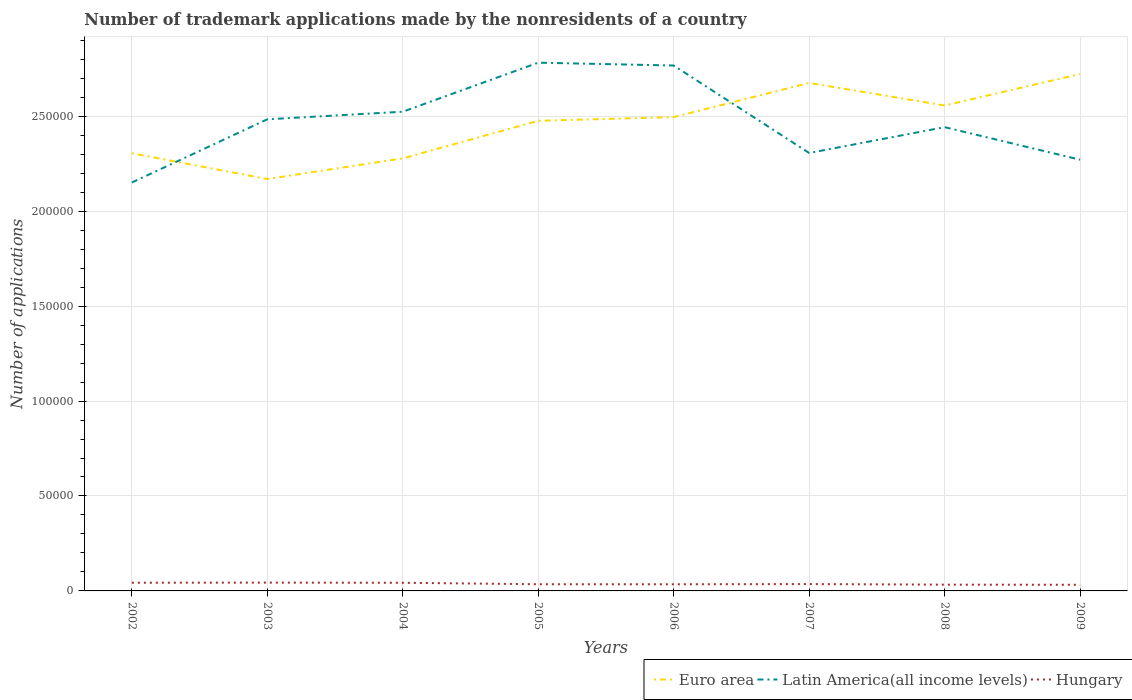How many different coloured lines are there?
Give a very brief answer. 3. Across all years, what is the maximum number of trademark applications made by the nonresidents in Hungary?
Ensure brevity in your answer.  3240. In which year was the number of trademark applications made by the nonresidents in Hungary maximum?
Offer a very short reply. 2009. What is the total number of trademark applications made by the nonresidents in Hungary in the graph?
Provide a short and direct response. 21. What is the difference between the highest and the second highest number of trademark applications made by the nonresidents in Latin America(all income levels)?
Give a very brief answer. 6.31e+04. Is the number of trademark applications made by the nonresidents in Euro area strictly greater than the number of trademark applications made by the nonresidents in Hungary over the years?
Your answer should be compact. No. How many lines are there?
Your answer should be very brief. 3. Are the values on the major ticks of Y-axis written in scientific E-notation?
Give a very brief answer. No. Does the graph contain any zero values?
Keep it short and to the point. No. What is the title of the graph?
Give a very brief answer. Number of trademark applications made by the nonresidents of a country. What is the label or title of the X-axis?
Keep it short and to the point. Years. What is the label or title of the Y-axis?
Ensure brevity in your answer.  Number of applications. What is the Number of applications of Euro area in 2002?
Provide a succinct answer. 2.30e+05. What is the Number of applications in Latin America(all income levels) in 2002?
Your answer should be compact. 2.15e+05. What is the Number of applications in Hungary in 2002?
Make the answer very short. 4316. What is the Number of applications of Euro area in 2003?
Your answer should be compact. 2.17e+05. What is the Number of applications of Latin America(all income levels) in 2003?
Provide a succinct answer. 2.48e+05. What is the Number of applications in Hungary in 2003?
Ensure brevity in your answer.  4386. What is the Number of applications of Euro area in 2004?
Provide a short and direct response. 2.28e+05. What is the Number of applications of Latin America(all income levels) in 2004?
Your answer should be very brief. 2.52e+05. What is the Number of applications in Hungary in 2004?
Ensure brevity in your answer.  4295. What is the Number of applications of Euro area in 2005?
Provide a succinct answer. 2.48e+05. What is the Number of applications in Latin America(all income levels) in 2005?
Keep it short and to the point. 2.78e+05. What is the Number of applications of Hungary in 2005?
Make the answer very short. 3515. What is the Number of applications of Euro area in 2006?
Your answer should be compact. 2.50e+05. What is the Number of applications of Latin America(all income levels) in 2006?
Give a very brief answer. 2.77e+05. What is the Number of applications in Hungary in 2006?
Offer a terse response. 3492. What is the Number of applications of Euro area in 2007?
Your answer should be very brief. 2.68e+05. What is the Number of applications in Latin America(all income levels) in 2007?
Ensure brevity in your answer.  2.31e+05. What is the Number of applications in Hungary in 2007?
Ensure brevity in your answer.  3615. What is the Number of applications of Euro area in 2008?
Provide a short and direct response. 2.56e+05. What is the Number of applications of Latin America(all income levels) in 2008?
Ensure brevity in your answer.  2.44e+05. What is the Number of applications of Hungary in 2008?
Provide a short and direct response. 3296. What is the Number of applications of Euro area in 2009?
Ensure brevity in your answer.  2.72e+05. What is the Number of applications of Latin America(all income levels) in 2009?
Your answer should be compact. 2.27e+05. What is the Number of applications of Hungary in 2009?
Your answer should be very brief. 3240. Across all years, what is the maximum Number of applications in Euro area?
Give a very brief answer. 2.72e+05. Across all years, what is the maximum Number of applications in Latin America(all income levels)?
Keep it short and to the point. 2.78e+05. Across all years, what is the maximum Number of applications of Hungary?
Provide a succinct answer. 4386. Across all years, what is the minimum Number of applications of Euro area?
Your response must be concise. 2.17e+05. Across all years, what is the minimum Number of applications of Latin America(all income levels)?
Give a very brief answer. 2.15e+05. Across all years, what is the minimum Number of applications in Hungary?
Offer a very short reply. 3240. What is the total Number of applications in Euro area in the graph?
Your response must be concise. 1.97e+06. What is the total Number of applications in Latin America(all income levels) in the graph?
Your answer should be compact. 1.97e+06. What is the total Number of applications in Hungary in the graph?
Your response must be concise. 3.02e+04. What is the difference between the Number of applications of Euro area in 2002 and that in 2003?
Your answer should be very brief. 1.36e+04. What is the difference between the Number of applications in Latin America(all income levels) in 2002 and that in 2003?
Make the answer very short. -3.33e+04. What is the difference between the Number of applications in Hungary in 2002 and that in 2003?
Keep it short and to the point. -70. What is the difference between the Number of applications in Euro area in 2002 and that in 2004?
Your answer should be very brief. 2697. What is the difference between the Number of applications in Latin America(all income levels) in 2002 and that in 2004?
Your answer should be compact. -3.73e+04. What is the difference between the Number of applications in Hungary in 2002 and that in 2004?
Your answer should be very brief. 21. What is the difference between the Number of applications of Euro area in 2002 and that in 2005?
Keep it short and to the point. -1.71e+04. What is the difference between the Number of applications in Latin America(all income levels) in 2002 and that in 2005?
Ensure brevity in your answer.  -6.31e+04. What is the difference between the Number of applications in Hungary in 2002 and that in 2005?
Give a very brief answer. 801. What is the difference between the Number of applications in Euro area in 2002 and that in 2006?
Your answer should be very brief. -1.90e+04. What is the difference between the Number of applications in Latin America(all income levels) in 2002 and that in 2006?
Provide a succinct answer. -6.16e+04. What is the difference between the Number of applications in Hungary in 2002 and that in 2006?
Offer a terse response. 824. What is the difference between the Number of applications of Euro area in 2002 and that in 2007?
Keep it short and to the point. -3.70e+04. What is the difference between the Number of applications of Latin America(all income levels) in 2002 and that in 2007?
Provide a short and direct response. -1.55e+04. What is the difference between the Number of applications of Hungary in 2002 and that in 2007?
Make the answer very short. 701. What is the difference between the Number of applications of Euro area in 2002 and that in 2008?
Your response must be concise. -2.52e+04. What is the difference between the Number of applications in Latin America(all income levels) in 2002 and that in 2008?
Offer a very short reply. -2.91e+04. What is the difference between the Number of applications of Hungary in 2002 and that in 2008?
Your answer should be compact. 1020. What is the difference between the Number of applications of Euro area in 2002 and that in 2009?
Your answer should be very brief. -4.17e+04. What is the difference between the Number of applications of Latin America(all income levels) in 2002 and that in 2009?
Your answer should be very brief. -1.20e+04. What is the difference between the Number of applications of Hungary in 2002 and that in 2009?
Your answer should be compact. 1076. What is the difference between the Number of applications in Euro area in 2003 and that in 2004?
Your response must be concise. -1.09e+04. What is the difference between the Number of applications in Latin America(all income levels) in 2003 and that in 2004?
Give a very brief answer. -4004. What is the difference between the Number of applications of Hungary in 2003 and that in 2004?
Offer a very short reply. 91. What is the difference between the Number of applications of Euro area in 2003 and that in 2005?
Provide a succinct answer. -3.07e+04. What is the difference between the Number of applications in Latin America(all income levels) in 2003 and that in 2005?
Your response must be concise. -2.98e+04. What is the difference between the Number of applications of Hungary in 2003 and that in 2005?
Ensure brevity in your answer.  871. What is the difference between the Number of applications in Euro area in 2003 and that in 2006?
Your answer should be compact. -3.26e+04. What is the difference between the Number of applications of Latin America(all income levels) in 2003 and that in 2006?
Make the answer very short. -2.83e+04. What is the difference between the Number of applications of Hungary in 2003 and that in 2006?
Your answer should be compact. 894. What is the difference between the Number of applications in Euro area in 2003 and that in 2007?
Provide a succinct answer. -5.06e+04. What is the difference between the Number of applications in Latin America(all income levels) in 2003 and that in 2007?
Your answer should be very brief. 1.77e+04. What is the difference between the Number of applications in Hungary in 2003 and that in 2007?
Give a very brief answer. 771. What is the difference between the Number of applications of Euro area in 2003 and that in 2008?
Keep it short and to the point. -3.87e+04. What is the difference between the Number of applications in Latin America(all income levels) in 2003 and that in 2008?
Provide a succinct answer. 4135. What is the difference between the Number of applications in Hungary in 2003 and that in 2008?
Offer a terse response. 1090. What is the difference between the Number of applications of Euro area in 2003 and that in 2009?
Your answer should be compact. -5.53e+04. What is the difference between the Number of applications in Latin America(all income levels) in 2003 and that in 2009?
Your answer should be compact. 2.13e+04. What is the difference between the Number of applications in Hungary in 2003 and that in 2009?
Provide a succinct answer. 1146. What is the difference between the Number of applications in Euro area in 2004 and that in 2005?
Provide a succinct answer. -1.98e+04. What is the difference between the Number of applications of Latin America(all income levels) in 2004 and that in 2005?
Make the answer very short. -2.58e+04. What is the difference between the Number of applications of Hungary in 2004 and that in 2005?
Keep it short and to the point. 780. What is the difference between the Number of applications of Euro area in 2004 and that in 2006?
Make the answer very short. -2.17e+04. What is the difference between the Number of applications of Latin America(all income levels) in 2004 and that in 2006?
Ensure brevity in your answer.  -2.43e+04. What is the difference between the Number of applications of Hungary in 2004 and that in 2006?
Your answer should be very brief. 803. What is the difference between the Number of applications of Euro area in 2004 and that in 2007?
Offer a very short reply. -3.97e+04. What is the difference between the Number of applications in Latin America(all income levels) in 2004 and that in 2007?
Keep it short and to the point. 2.17e+04. What is the difference between the Number of applications in Hungary in 2004 and that in 2007?
Your answer should be very brief. 680. What is the difference between the Number of applications in Euro area in 2004 and that in 2008?
Give a very brief answer. -2.78e+04. What is the difference between the Number of applications of Latin America(all income levels) in 2004 and that in 2008?
Provide a short and direct response. 8139. What is the difference between the Number of applications of Hungary in 2004 and that in 2008?
Offer a terse response. 999. What is the difference between the Number of applications in Euro area in 2004 and that in 2009?
Make the answer very short. -4.44e+04. What is the difference between the Number of applications in Latin America(all income levels) in 2004 and that in 2009?
Ensure brevity in your answer.  2.53e+04. What is the difference between the Number of applications of Hungary in 2004 and that in 2009?
Your response must be concise. 1055. What is the difference between the Number of applications of Euro area in 2005 and that in 2006?
Ensure brevity in your answer.  -1953. What is the difference between the Number of applications in Latin America(all income levels) in 2005 and that in 2006?
Provide a short and direct response. 1492. What is the difference between the Number of applications of Euro area in 2005 and that in 2007?
Keep it short and to the point. -1.99e+04. What is the difference between the Number of applications in Latin America(all income levels) in 2005 and that in 2007?
Offer a terse response. 4.76e+04. What is the difference between the Number of applications of Hungary in 2005 and that in 2007?
Your response must be concise. -100. What is the difference between the Number of applications in Euro area in 2005 and that in 2008?
Your answer should be very brief. -8058. What is the difference between the Number of applications in Latin America(all income levels) in 2005 and that in 2008?
Ensure brevity in your answer.  3.40e+04. What is the difference between the Number of applications of Hungary in 2005 and that in 2008?
Ensure brevity in your answer.  219. What is the difference between the Number of applications of Euro area in 2005 and that in 2009?
Make the answer very short. -2.46e+04. What is the difference between the Number of applications in Latin America(all income levels) in 2005 and that in 2009?
Make the answer very short. 5.11e+04. What is the difference between the Number of applications in Hungary in 2005 and that in 2009?
Give a very brief answer. 275. What is the difference between the Number of applications in Euro area in 2006 and that in 2007?
Give a very brief answer. -1.80e+04. What is the difference between the Number of applications in Latin America(all income levels) in 2006 and that in 2007?
Ensure brevity in your answer.  4.61e+04. What is the difference between the Number of applications of Hungary in 2006 and that in 2007?
Give a very brief answer. -123. What is the difference between the Number of applications of Euro area in 2006 and that in 2008?
Give a very brief answer. -6105. What is the difference between the Number of applications of Latin America(all income levels) in 2006 and that in 2008?
Provide a succinct answer. 3.25e+04. What is the difference between the Number of applications in Hungary in 2006 and that in 2008?
Your answer should be very brief. 196. What is the difference between the Number of applications in Euro area in 2006 and that in 2009?
Offer a terse response. -2.27e+04. What is the difference between the Number of applications in Latin America(all income levels) in 2006 and that in 2009?
Ensure brevity in your answer.  4.96e+04. What is the difference between the Number of applications of Hungary in 2006 and that in 2009?
Offer a terse response. 252. What is the difference between the Number of applications in Euro area in 2007 and that in 2008?
Give a very brief answer. 1.19e+04. What is the difference between the Number of applications of Latin America(all income levels) in 2007 and that in 2008?
Ensure brevity in your answer.  -1.36e+04. What is the difference between the Number of applications in Hungary in 2007 and that in 2008?
Provide a succinct answer. 319. What is the difference between the Number of applications in Euro area in 2007 and that in 2009?
Your response must be concise. -4700. What is the difference between the Number of applications of Latin America(all income levels) in 2007 and that in 2009?
Give a very brief answer. 3539. What is the difference between the Number of applications of Hungary in 2007 and that in 2009?
Ensure brevity in your answer.  375. What is the difference between the Number of applications in Euro area in 2008 and that in 2009?
Your answer should be very brief. -1.66e+04. What is the difference between the Number of applications in Latin America(all income levels) in 2008 and that in 2009?
Give a very brief answer. 1.71e+04. What is the difference between the Number of applications in Hungary in 2008 and that in 2009?
Your answer should be very brief. 56. What is the difference between the Number of applications in Euro area in 2002 and the Number of applications in Latin America(all income levels) in 2003?
Make the answer very short. -1.79e+04. What is the difference between the Number of applications of Euro area in 2002 and the Number of applications of Hungary in 2003?
Give a very brief answer. 2.26e+05. What is the difference between the Number of applications of Latin America(all income levels) in 2002 and the Number of applications of Hungary in 2003?
Provide a succinct answer. 2.11e+05. What is the difference between the Number of applications of Euro area in 2002 and the Number of applications of Latin America(all income levels) in 2004?
Provide a short and direct response. -2.19e+04. What is the difference between the Number of applications in Euro area in 2002 and the Number of applications in Hungary in 2004?
Your answer should be compact. 2.26e+05. What is the difference between the Number of applications in Latin America(all income levels) in 2002 and the Number of applications in Hungary in 2004?
Provide a succinct answer. 2.11e+05. What is the difference between the Number of applications in Euro area in 2002 and the Number of applications in Latin America(all income levels) in 2005?
Provide a short and direct response. -4.77e+04. What is the difference between the Number of applications of Euro area in 2002 and the Number of applications of Hungary in 2005?
Your answer should be very brief. 2.27e+05. What is the difference between the Number of applications in Latin America(all income levels) in 2002 and the Number of applications in Hungary in 2005?
Offer a terse response. 2.12e+05. What is the difference between the Number of applications in Euro area in 2002 and the Number of applications in Latin America(all income levels) in 2006?
Your answer should be compact. -4.62e+04. What is the difference between the Number of applications in Euro area in 2002 and the Number of applications in Hungary in 2006?
Give a very brief answer. 2.27e+05. What is the difference between the Number of applications of Latin America(all income levels) in 2002 and the Number of applications of Hungary in 2006?
Offer a terse response. 2.12e+05. What is the difference between the Number of applications in Euro area in 2002 and the Number of applications in Latin America(all income levels) in 2007?
Keep it short and to the point. -140. What is the difference between the Number of applications of Euro area in 2002 and the Number of applications of Hungary in 2007?
Offer a terse response. 2.27e+05. What is the difference between the Number of applications of Latin America(all income levels) in 2002 and the Number of applications of Hungary in 2007?
Keep it short and to the point. 2.11e+05. What is the difference between the Number of applications of Euro area in 2002 and the Number of applications of Latin America(all income levels) in 2008?
Your answer should be compact. -1.37e+04. What is the difference between the Number of applications of Euro area in 2002 and the Number of applications of Hungary in 2008?
Offer a very short reply. 2.27e+05. What is the difference between the Number of applications in Latin America(all income levels) in 2002 and the Number of applications in Hungary in 2008?
Offer a terse response. 2.12e+05. What is the difference between the Number of applications in Euro area in 2002 and the Number of applications in Latin America(all income levels) in 2009?
Offer a very short reply. 3399. What is the difference between the Number of applications in Euro area in 2002 and the Number of applications in Hungary in 2009?
Your response must be concise. 2.27e+05. What is the difference between the Number of applications of Latin America(all income levels) in 2002 and the Number of applications of Hungary in 2009?
Provide a short and direct response. 2.12e+05. What is the difference between the Number of applications in Euro area in 2003 and the Number of applications in Latin America(all income levels) in 2004?
Offer a terse response. -3.55e+04. What is the difference between the Number of applications of Euro area in 2003 and the Number of applications of Hungary in 2004?
Make the answer very short. 2.13e+05. What is the difference between the Number of applications of Latin America(all income levels) in 2003 and the Number of applications of Hungary in 2004?
Your answer should be very brief. 2.44e+05. What is the difference between the Number of applications of Euro area in 2003 and the Number of applications of Latin America(all income levels) in 2005?
Your answer should be very brief. -6.13e+04. What is the difference between the Number of applications in Euro area in 2003 and the Number of applications in Hungary in 2005?
Keep it short and to the point. 2.13e+05. What is the difference between the Number of applications of Latin America(all income levels) in 2003 and the Number of applications of Hungary in 2005?
Your answer should be compact. 2.45e+05. What is the difference between the Number of applications in Euro area in 2003 and the Number of applications in Latin America(all income levels) in 2006?
Keep it short and to the point. -5.98e+04. What is the difference between the Number of applications in Euro area in 2003 and the Number of applications in Hungary in 2006?
Offer a terse response. 2.13e+05. What is the difference between the Number of applications in Latin America(all income levels) in 2003 and the Number of applications in Hungary in 2006?
Keep it short and to the point. 2.45e+05. What is the difference between the Number of applications of Euro area in 2003 and the Number of applications of Latin America(all income levels) in 2007?
Give a very brief answer. -1.37e+04. What is the difference between the Number of applications of Euro area in 2003 and the Number of applications of Hungary in 2007?
Your answer should be compact. 2.13e+05. What is the difference between the Number of applications of Latin America(all income levels) in 2003 and the Number of applications of Hungary in 2007?
Make the answer very short. 2.45e+05. What is the difference between the Number of applications in Euro area in 2003 and the Number of applications in Latin America(all income levels) in 2008?
Your response must be concise. -2.73e+04. What is the difference between the Number of applications in Euro area in 2003 and the Number of applications in Hungary in 2008?
Provide a succinct answer. 2.14e+05. What is the difference between the Number of applications in Latin America(all income levels) in 2003 and the Number of applications in Hungary in 2008?
Your response must be concise. 2.45e+05. What is the difference between the Number of applications of Euro area in 2003 and the Number of applications of Latin America(all income levels) in 2009?
Keep it short and to the point. -1.02e+04. What is the difference between the Number of applications in Euro area in 2003 and the Number of applications in Hungary in 2009?
Provide a succinct answer. 2.14e+05. What is the difference between the Number of applications in Latin America(all income levels) in 2003 and the Number of applications in Hungary in 2009?
Make the answer very short. 2.45e+05. What is the difference between the Number of applications in Euro area in 2004 and the Number of applications in Latin America(all income levels) in 2005?
Your answer should be very brief. -5.04e+04. What is the difference between the Number of applications of Euro area in 2004 and the Number of applications of Hungary in 2005?
Your answer should be compact. 2.24e+05. What is the difference between the Number of applications in Latin America(all income levels) in 2004 and the Number of applications in Hungary in 2005?
Ensure brevity in your answer.  2.49e+05. What is the difference between the Number of applications of Euro area in 2004 and the Number of applications of Latin America(all income levels) in 2006?
Your response must be concise. -4.89e+04. What is the difference between the Number of applications in Euro area in 2004 and the Number of applications in Hungary in 2006?
Offer a very short reply. 2.24e+05. What is the difference between the Number of applications in Latin America(all income levels) in 2004 and the Number of applications in Hungary in 2006?
Offer a terse response. 2.49e+05. What is the difference between the Number of applications of Euro area in 2004 and the Number of applications of Latin America(all income levels) in 2007?
Ensure brevity in your answer.  -2837. What is the difference between the Number of applications of Euro area in 2004 and the Number of applications of Hungary in 2007?
Your answer should be very brief. 2.24e+05. What is the difference between the Number of applications in Latin America(all income levels) in 2004 and the Number of applications in Hungary in 2007?
Offer a very short reply. 2.49e+05. What is the difference between the Number of applications of Euro area in 2004 and the Number of applications of Latin America(all income levels) in 2008?
Provide a succinct answer. -1.64e+04. What is the difference between the Number of applications in Euro area in 2004 and the Number of applications in Hungary in 2008?
Your answer should be compact. 2.25e+05. What is the difference between the Number of applications of Latin America(all income levels) in 2004 and the Number of applications of Hungary in 2008?
Make the answer very short. 2.49e+05. What is the difference between the Number of applications of Euro area in 2004 and the Number of applications of Latin America(all income levels) in 2009?
Provide a short and direct response. 702. What is the difference between the Number of applications of Euro area in 2004 and the Number of applications of Hungary in 2009?
Your answer should be compact. 2.25e+05. What is the difference between the Number of applications of Latin America(all income levels) in 2004 and the Number of applications of Hungary in 2009?
Offer a very short reply. 2.49e+05. What is the difference between the Number of applications in Euro area in 2005 and the Number of applications in Latin America(all income levels) in 2006?
Ensure brevity in your answer.  -2.91e+04. What is the difference between the Number of applications of Euro area in 2005 and the Number of applications of Hungary in 2006?
Your answer should be very brief. 2.44e+05. What is the difference between the Number of applications in Latin America(all income levels) in 2005 and the Number of applications in Hungary in 2006?
Your answer should be very brief. 2.75e+05. What is the difference between the Number of applications in Euro area in 2005 and the Number of applications in Latin America(all income levels) in 2007?
Make the answer very short. 1.70e+04. What is the difference between the Number of applications of Euro area in 2005 and the Number of applications of Hungary in 2007?
Make the answer very short. 2.44e+05. What is the difference between the Number of applications of Latin America(all income levels) in 2005 and the Number of applications of Hungary in 2007?
Offer a very short reply. 2.75e+05. What is the difference between the Number of applications in Euro area in 2005 and the Number of applications in Latin America(all income levels) in 2008?
Offer a very short reply. 3350. What is the difference between the Number of applications in Euro area in 2005 and the Number of applications in Hungary in 2008?
Provide a succinct answer. 2.44e+05. What is the difference between the Number of applications in Latin America(all income levels) in 2005 and the Number of applications in Hungary in 2008?
Make the answer very short. 2.75e+05. What is the difference between the Number of applications in Euro area in 2005 and the Number of applications in Latin America(all income levels) in 2009?
Keep it short and to the point. 2.05e+04. What is the difference between the Number of applications in Euro area in 2005 and the Number of applications in Hungary in 2009?
Provide a succinct answer. 2.44e+05. What is the difference between the Number of applications of Latin America(all income levels) in 2005 and the Number of applications of Hungary in 2009?
Your answer should be very brief. 2.75e+05. What is the difference between the Number of applications in Euro area in 2006 and the Number of applications in Latin America(all income levels) in 2007?
Provide a short and direct response. 1.89e+04. What is the difference between the Number of applications of Euro area in 2006 and the Number of applications of Hungary in 2007?
Provide a succinct answer. 2.46e+05. What is the difference between the Number of applications in Latin America(all income levels) in 2006 and the Number of applications in Hungary in 2007?
Offer a very short reply. 2.73e+05. What is the difference between the Number of applications in Euro area in 2006 and the Number of applications in Latin America(all income levels) in 2008?
Your response must be concise. 5303. What is the difference between the Number of applications of Euro area in 2006 and the Number of applications of Hungary in 2008?
Give a very brief answer. 2.46e+05. What is the difference between the Number of applications in Latin America(all income levels) in 2006 and the Number of applications in Hungary in 2008?
Offer a terse response. 2.73e+05. What is the difference between the Number of applications of Euro area in 2006 and the Number of applications of Latin America(all income levels) in 2009?
Your answer should be compact. 2.24e+04. What is the difference between the Number of applications of Euro area in 2006 and the Number of applications of Hungary in 2009?
Ensure brevity in your answer.  2.46e+05. What is the difference between the Number of applications of Latin America(all income levels) in 2006 and the Number of applications of Hungary in 2009?
Keep it short and to the point. 2.73e+05. What is the difference between the Number of applications in Euro area in 2007 and the Number of applications in Latin America(all income levels) in 2008?
Ensure brevity in your answer.  2.33e+04. What is the difference between the Number of applications in Euro area in 2007 and the Number of applications in Hungary in 2008?
Offer a terse response. 2.64e+05. What is the difference between the Number of applications in Latin America(all income levels) in 2007 and the Number of applications in Hungary in 2008?
Your answer should be compact. 2.27e+05. What is the difference between the Number of applications in Euro area in 2007 and the Number of applications in Latin America(all income levels) in 2009?
Provide a succinct answer. 4.04e+04. What is the difference between the Number of applications in Euro area in 2007 and the Number of applications in Hungary in 2009?
Provide a short and direct response. 2.64e+05. What is the difference between the Number of applications of Latin America(all income levels) in 2007 and the Number of applications of Hungary in 2009?
Your answer should be compact. 2.27e+05. What is the difference between the Number of applications in Euro area in 2008 and the Number of applications in Latin America(all income levels) in 2009?
Give a very brief answer. 2.86e+04. What is the difference between the Number of applications in Euro area in 2008 and the Number of applications in Hungary in 2009?
Keep it short and to the point. 2.52e+05. What is the difference between the Number of applications in Latin America(all income levels) in 2008 and the Number of applications in Hungary in 2009?
Offer a very short reply. 2.41e+05. What is the average Number of applications of Euro area per year?
Ensure brevity in your answer.  2.46e+05. What is the average Number of applications in Latin America(all income levels) per year?
Offer a very short reply. 2.47e+05. What is the average Number of applications in Hungary per year?
Your response must be concise. 3769.38. In the year 2002, what is the difference between the Number of applications of Euro area and Number of applications of Latin America(all income levels)?
Ensure brevity in your answer.  1.54e+04. In the year 2002, what is the difference between the Number of applications in Euro area and Number of applications in Hungary?
Make the answer very short. 2.26e+05. In the year 2002, what is the difference between the Number of applications in Latin America(all income levels) and Number of applications in Hungary?
Ensure brevity in your answer.  2.11e+05. In the year 2003, what is the difference between the Number of applications in Euro area and Number of applications in Latin America(all income levels)?
Offer a terse response. -3.14e+04. In the year 2003, what is the difference between the Number of applications of Euro area and Number of applications of Hungary?
Keep it short and to the point. 2.13e+05. In the year 2003, what is the difference between the Number of applications in Latin America(all income levels) and Number of applications in Hungary?
Provide a short and direct response. 2.44e+05. In the year 2004, what is the difference between the Number of applications of Euro area and Number of applications of Latin America(all income levels)?
Your response must be concise. -2.46e+04. In the year 2004, what is the difference between the Number of applications in Euro area and Number of applications in Hungary?
Give a very brief answer. 2.24e+05. In the year 2004, what is the difference between the Number of applications in Latin America(all income levels) and Number of applications in Hungary?
Your response must be concise. 2.48e+05. In the year 2005, what is the difference between the Number of applications in Euro area and Number of applications in Latin America(all income levels)?
Keep it short and to the point. -3.06e+04. In the year 2005, what is the difference between the Number of applications of Euro area and Number of applications of Hungary?
Offer a terse response. 2.44e+05. In the year 2005, what is the difference between the Number of applications of Latin America(all income levels) and Number of applications of Hungary?
Give a very brief answer. 2.75e+05. In the year 2006, what is the difference between the Number of applications of Euro area and Number of applications of Latin America(all income levels)?
Your answer should be compact. -2.72e+04. In the year 2006, what is the difference between the Number of applications of Euro area and Number of applications of Hungary?
Your response must be concise. 2.46e+05. In the year 2006, what is the difference between the Number of applications in Latin America(all income levels) and Number of applications in Hungary?
Make the answer very short. 2.73e+05. In the year 2007, what is the difference between the Number of applications in Euro area and Number of applications in Latin America(all income levels)?
Offer a very short reply. 3.69e+04. In the year 2007, what is the difference between the Number of applications in Euro area and Number of applications in Hungary?
Give a very brief answer. 2.64e+05. In the year 2007, what is the difference between the Number of applications of Latin America(all income levels) and Number of applications of Hungary?
Ensure brevity in your answer.  2.27e+05. In the year 2008, what is the difference between the Number of applications of Euro area and Number of applications of Latin America(all income levels)?
Give a very brief answer. 1.14e+04. In the year 2008, what is the difference between the Number of applications in Euro area and Number of applications in Hungary?
Make the answer very short. 2.52e+05. In the year 2008, what is the difference between the Number of applications of Latin America(all income levels) and Number of applications of Hungary?
Offer a terse response. 2.41e+05. In the year 2009, what is the difference between the Number of applications of Euro area and Number of applications of Latin America(all income levels)?
Your answer should be compact. 4.51e+04. In the year 2009, what is the difference between the Number of applications in Euro area and Number of applications in Hungary?
Offer a terse response. 2.69e+05. In the year 2009, what is the difference between the Number of applications of Latin America(all income levels) and Number of applications of Hungary?
Make the answer very short. 2.24e+05. What is the ratio of the Number of applications of Euro area in 2002 to that in 2003?
Offer a terse response. 1.06. What is the ratio of the Number of applications in Latin America(all income levels) in 2002 to that in 2003?
Give a very brief answer. 0.87. What is the ratio of the Number of applications in Euro area in 2002 to that in 2004?
Offer a terse response. 1.01. What is the ratio of the Number of applications of Latin America(all income levels) in 2002 to that in 2004?
Give a very brief answer. 0.85. What is the ratio of the Number of applications of Hungary in 2002 to that in 2004?
Keep it short and to the point. 1. What is the ratio of the Number of applications of Euro area in 2002 to that in 2005?
Your response must be concise. 0.93. What is the ratio of the Number of applications of Latin America(all income levels) in 2002 to that in 2005?
Make the answer very short. 0.77. What is the ratio of the Number of applications of Hungary in 2002 to that in 2005?
Keep it short and to the point. 1.23. What is the ratio of the Number of applications in Euro area in 2002 to that in 2006?
Ensure brevity in your answer.  0.92. What is the ratio of the Number of applications of Latin America(all income levels) in 2002 to that in 2006?
Your answer should be very brief. 0.78. What is the ratio of the Number of applications in Hungary in 2002 to that in 2006?
Your answer should be compact. 1.24. What is the ratio of the Number of applications in Euro area in 2002 to that in 2007?
Provide a short and direct response. 0.86. What is the ratio of the Number of applications of Latin America(all income levels) in 2002 to that in 2007?
Your response must be concise. 0.93. What is the ratio of the Number of applications of Hungary in 2002 to that in 2007?
Offer a very short reply. 1.19. What is the ratio of the Number of applications of Euro area in 2002 to that in 2008?
Your answer should be very brief. 0.9. What is the ratio of the Number of applications in Latin America(all income levels) in 2002 to that in 2008?
Give a very brief answer. 0.88. What is the ratio of the Number of applications of Hungary in 2002 to that in 2008?
Provide a short and direct response. 1.31. What is the ratio of the Number of applications of Euro area in 2002 to that in 2009?
Offer a very short reply. 0.85. What is the ratio of the Number of applications of Latin America(all income levels) in 2002 to that in 2009?
Offer a terse response. 0.95. What is the ratio of the Number of applications of Hungary in 2002 to that in 2009?
Your answer should be very brief. 1.33. What is the ratio of the Number of applications of Euro area in 2003 to that in 2004?
Your answer should be very brief. 0.95. What is the ratio of the Number of applications in Latin America(all income levels) in 2003 to that in 2004?
Your answer should be very brief. 0.98. What is the ratio of the Number of applications in Hungary in 2003 to that in 2004?
Your answer should be very brief. 1.02. What is the ratio of the Number of applications of Euro area in 2003 to that in 2005?
Your answer should be compact. 0.88. What is the ratio of the Number of applications in Latin America(all income levels) in 2003 to that in 2005?
Provide a succinct answer. 0.89. What is the ratio of the Number of applications in Hungary in 2003 to that in 2005?
Give a very brief answer. 1.25. What is the ratio of the Number of applications in Euro area in 2003 to that in 2006?
Provide a succinct answer. 0.87. What is the ratio of the Number of applications of Latin America(all income levels) in 2003 to that in 2006?
Give a very brief answer. 0.9. What is the ratio of the Number of applications in Hungary in 2003 to that in 2006?
Give a very brief answer. 1.26. What is the ratio of the Number of applications in Euro area in 2003 to that in 2007?
Your response must be concise. 0.81. What is the ratio of the Number of applications of Hungary in 2003 to that in 2007?
Keep it short and to the point. 1.21. What is the ratio of the Number of applications in Euro area in 2003 to that in 2008?
Provide a succinct answer. 0.85. What is the ratio of the Number of applications in Latin America(all income levels) in 2003 to that in 2008?
Provide a short and direct response. 1.02. What is the ratio of the Number of applications in Hungary in 2003 to that in 2008?
Make the answer very short. 1.33. What is the ratio of the Number of applications of Euro area in 2003 to that in 2009?
Make the answer very short. 0.8. What is the ratio of the Number of applications in Latin America(all income levels) in 2003 to that in 2009?
Offer a very short reply. 1.09. What is the ratio of the Number of applications of Hungary in 2003 to that in 2009?
Provide a succinct answer. 1.35. What is the ratio of the Number of applications of Euro area in 2004 to that in 2005?
Your answer should be compact. 0.92. What is the ratio of the Number of applications in Latin America(all income levels) in 2004 to that in 2005?
Your response must be concise. 0.91. What is the ratio of the Number of applications in Hungary in 2004 to that in 2005?
Your response must be concise. 1.22. What is the ratio of the Number of applications in Euro area in 2004 to that in 2006?
Give a very brief answer. 0.91. What is the ratio of the Number of applications of Latin America(all income levels) in 2004 to that in 2006?
Ensure brevity in your answer.  0.91. What is the ratio of the Number of applications of Hungary in 2004 to that in 2006?
Offer a terse response. 1.23. What is the ratio of the Number of applications of Euro area in 2004 to that in 2007?
Make the answer very short. 0.85. What is the ratio of the Number of applications of Latin America(all income levels) in 2004 to that in 2007?
Offer a very short reply. 1.09. What is the ratio of the Number of applications in Hungary in 2004 to that in 2007?
Ensure brevity in your answer.  1.19. What is the ratio of the Number of applications of Euro area in 2004 to that in 2008?
Offer a terse response. 0.89. What is the ratio of the Number of applications in Latin America(all income levels) in 2004 to that in 2008?
Offer a very short reply. 1.03. What is the ratio of the Number of applications of Hungary in 2004 to that in 2008?
Offer a terse response. 1.3. What is the ratio of the Number of applications of Euro area in 2004 to that in 2009?
Make the answer very short. 0.84. What is the ratio of the Number of applications in Latin America(all income levels) in 2004 to that in 2009?
Your response must be concise. 1.11. What is the ratio of the Number of applications of Hungary in 2004 to that in 2009?
Ensure brevity in your answer.  1.33. What is the ratio of the Number of applications of Latin America(all income levels) in 2005 to that in 2006?
Provide a succinct answer. 1.01. What is the ratio of the Number of applications in Hungary in 2005 to that in 2006?
Ensure brevity in your answer.  1.01. What is the ratio of the Number of applications of Euro area in 2005 to that in 2007?
Make the answer very short. 0.93. What is the ratio of the Number of applications in Latin America(all income levels) in 2005 to that in 2007?
Offer a very short reply. 1.21. What is the ratio of the Number of applications of Hungary in 2005 to that in 2007?
Your response must be concise. 0.97. What is the ratio of the Number of applications in Euro area in 2005 to that in 2008?
Your answer should be very brief. 0.97. What is the ratio of the Number of applications of Latin America(all income levels) in 2005 to that in 2008?
Keep it short and to the point. 1.14. What is the ratio of the Number of applications of Hungary in 2005 to that in 2008?
Offer a terse response. 1.07. What is the ratio of the Number of applications in Euro area in 2005 to that in 2009?
Your answer should be very brief. 0.91. What is the ratio of the Number of applications of Latin America(all income levels) in 2005 to that in 2009?
Offer a very short reply. 1.23. What is the ratio of the Number of applications in Hungary in 2005 to that in 2009?
Make the answer very short. 1.08. What is the ratio of the Number of applications in Euro area in 2006 to that in 2007?
Offer a terse response. 0.93. What is the ratio of the Number of applications in Latin America(all income levels) in 2006 to that in 2007?
Offer a terse response. 1.2. What is the ratio of the Number of applications in Hungary in 2006 to that in 2007?
Provide a short and direct response. 0.97. What is the ratio of the Number of applications of Euro area in 2006 to that in 2008?
Your answer should be very brief. 0.98. What is the ratio of the Number of applications in Latin America(all income levels) in 2006 to that in 2008?
Make the answer very short. 1.13. What is the ratio of the Number of applications in Hungary in 2006 to that in 2008?
Ensure brevity in your answer.  1.06. What is the ratio of the Number of applications in Euro area in 2006 to that in 2009?
Keep it short and to the point. 0.92. What is the ratio of the Number of applications in Latin America(all income levels) in 2006 to that in 2009?
Ensure brevity in your answer.  1.22. What is the ratio of the Number of applications of Hungary in 2006 to that in 2009?
Your response must be concise. 1.08. What is the ratio of the Number of applications in Euro area in 2007 to that in 2008?
Offer a very short reply. 1.05. What is the ratio of the Number of applications in Latin America(all income levels) in 2007 to that in 2008?
Offer a terse response. 0.94. What is the ratio of the Number of applications in Hungary in 2007 to that in 2008?
Offer a very short reply. 1.1. What is the ratio of the Number of applications of Euro area in 2007 to that in 2009?
Ensure brevity in your answer.  0.98. What is the ratio of the Number of applications in Latin America(all income levels) in 2007 to that in 2009?
Your response must be concise. 1.02. What is the ratio of the Number of applications in Hungary in 2007 to that in 2009?
Your response must be concise. 1.12. What is the ratio of the Number of applications of Euro area in 2008 to that in 2009?
Give a very brief answer. 0.94. What is the ratio of the Number of applications of Latin America(all income levels) in 2008 to that in 2009?
Keep it short and to the point. 1.08. What is the ratio of the Number of applications of Hungary in 2008 to that in 2009?
Provide a succinct answer. 1.02. What is the difference between the highest and the second highest Number of applications in Euro area?
Make the answer very short. 4700. What is the difference between the highest and the second highest Number of applications of Latin America(all income levels)?
Make the answer very short. 1492. What is the difference between the highest and the lowest Number of applications of Euro area?
Keep it short and to the point. 5.53e+04. What is the difference between the highest and the lowest Number of applications of Latin America(all income levels)?
Make the answer very short. 6.31e+04. What is the difference between the highest and the lowest Number of applications of Hungary?
Your answer should be very brief. 1146. 